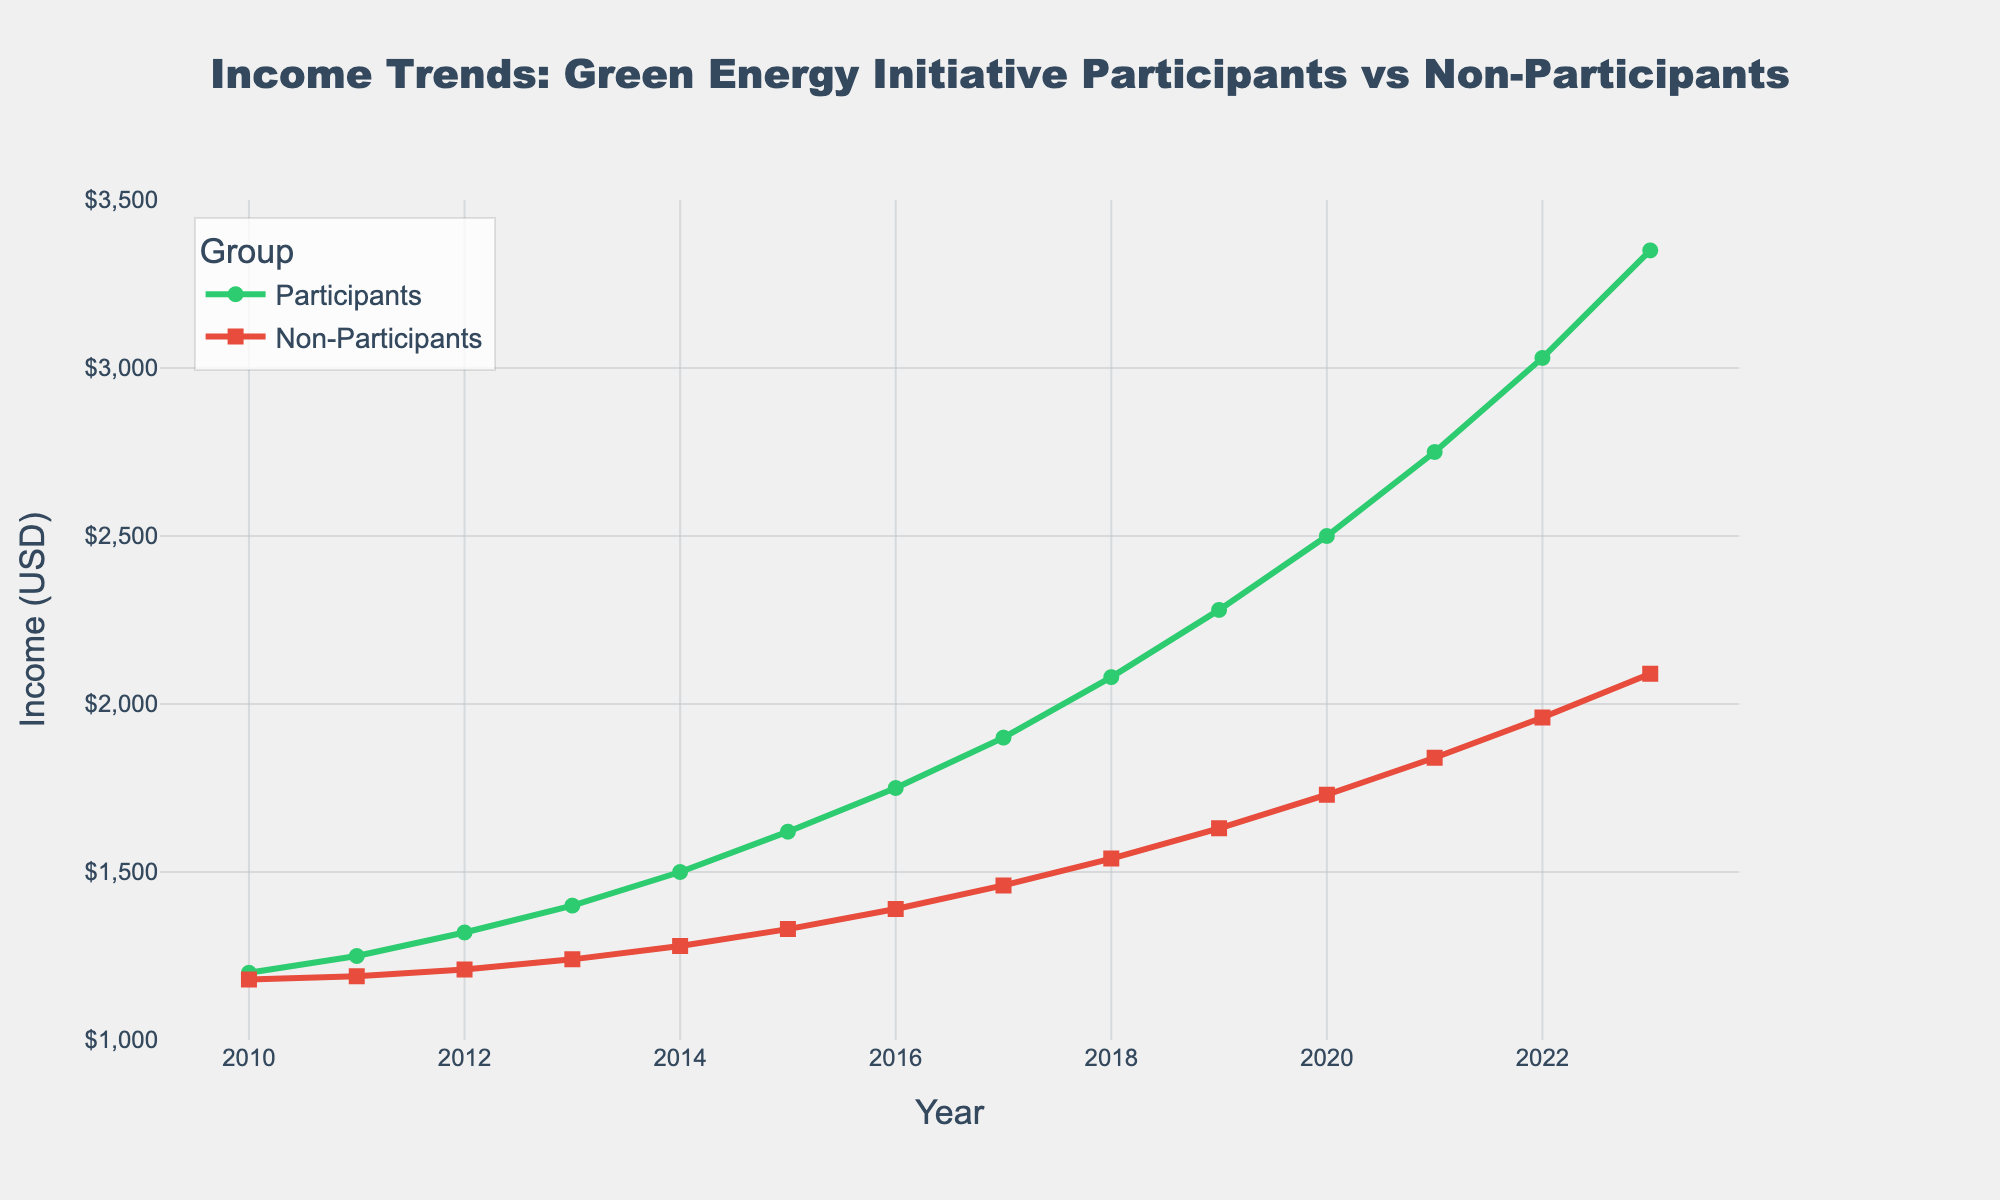What is the income difference between participants and non-participants in 2010? To find the difference, subtract the income of non-participants from the income of participants for the year 2010. That is, 1200 - 1180 = 20.
Answer: 20 In which year did participants' income surpass $2000? Observe the line chart for participants and locate the year where the income value exceeds $2000. From the chart, this happens in 2018.
Answer: 2018 By how much did participants' income grow from 2010 to 2023? Subtract the income of participants in 2010 from their income in 2023. That is, 3350 - 1200 = 2150.
Answer: 2150 Compare the income growth rates of participants and non-participants from 2010 to 2023. Who had a higher growth rate? Calculate the growth for both participants and non-participants. For participants: 3350 - 1200 = 2150. For non-participants: 2090 - 1180 = 910. Since 2150 > 910, participants had a higher growth rate.
Answer: Participants Which year shows the largest income gap between participants and non-participants? Inspect the chart and find the year with the widest vertical distance between the green (participants) and red (non-participants) lines. The largest gap appears in 2023.
Answer: 2023 How many years did it take for participants' income to double since 2010? Identify the year when participants' income reached or exceeded twice the 2010 income: double of 1200 is 2400. This occurred in 2020. Therefore, it took 2020 - 2010 = 10 years.
Answer: 10 What is the average income of non-participants over the years? Calculate the sum of non-participants' income from 2010 to 2023 and divide by the number of years (14). 
Sum = 1180 + 1190 + 1210 + 1240 + 1280 + 1330 + 1390 + 1460 + 1540 + 1630 + 1730 + 1840 + 1960 + 2090 = 22070.
Average = 22070 / 14 ≈ 1576.43.
Answer: 1576.43 When did the difference in income between participants and non-participants exceed $1000 for the first time? Find the first year where the difference between participants' and non-participants' income exceeds $1000. Calculation shows the difference exceeds $1000 for the first time in 2022 (3030 - 1960 = 1070).
Answer: 2022 